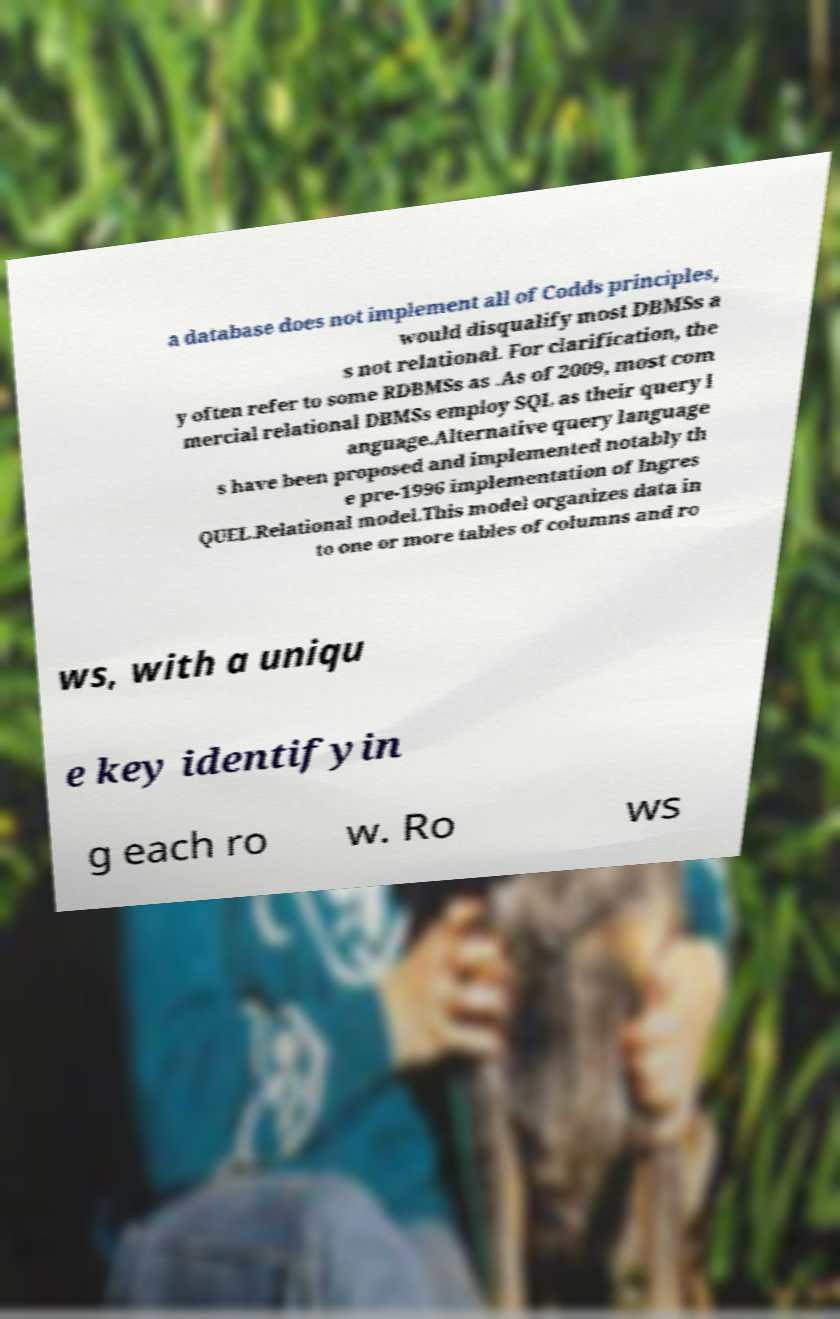Could you extract and type out the text from this image? a database does not implement all of Codds principles, would disqualify most DBMSs a s not relational. For clarification, the y often refer to some RDBMSs as .As of 2009, most com mercial relational DBMSs employ SQL as their query l anguage.Alternative query language s have been proposed and implemented notably th e pre-1996 implementation of Ingres QUEL.Relational model.This model organizes data in to one or more tables of columns and ro ws, with a uniqu e key identifyin g each ro w. Ro ws 